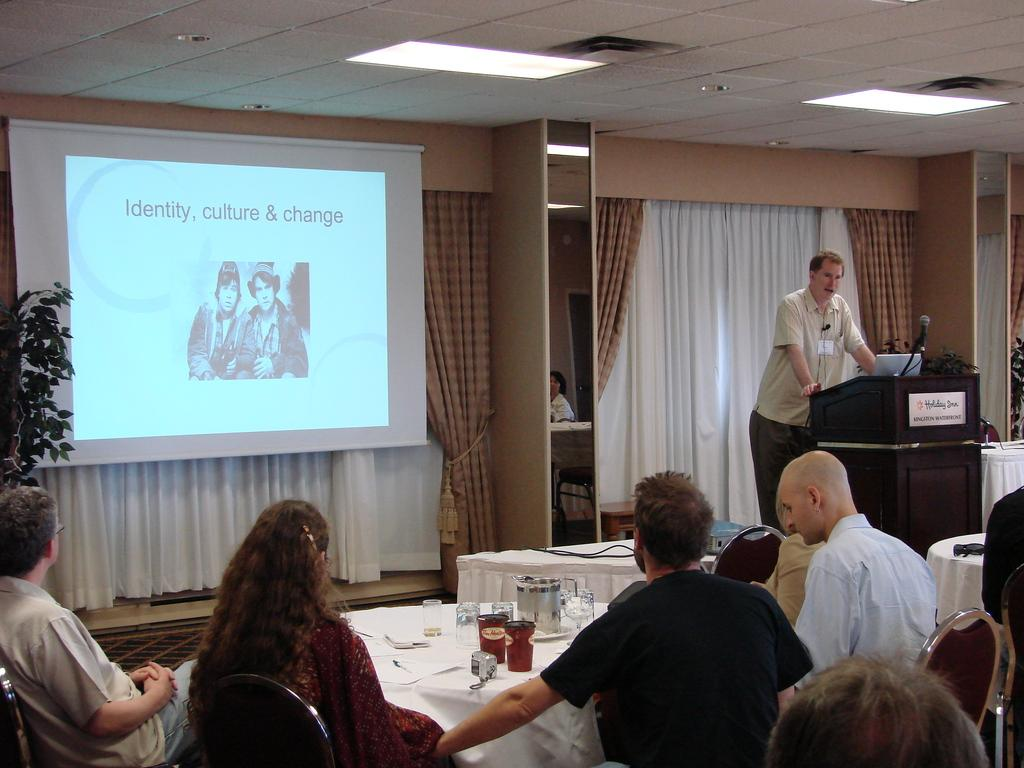Provide a one-sentence caption for the provided image. A man is speaking about "identity, culture & change". 